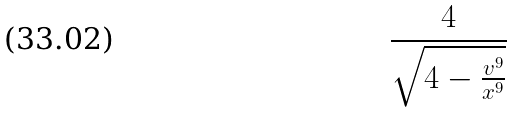<formula> <loc_0><loc_0><loc_500><loc_500>\frac { 4 } { \sqrt { 4 - \frac { v ^ { 9 } } { x ^ { 9 } } } }</formula> 